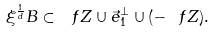Convert formula to latex. <formula><loc_0><loc_0><loc_500><loc_500>\xi ^ { \frac { 1 } { d } } B \subset \ f Z \cup \vec { e } _ { 1 } ^ { \perp } \cup ( - \ f Z ) .</formula> 